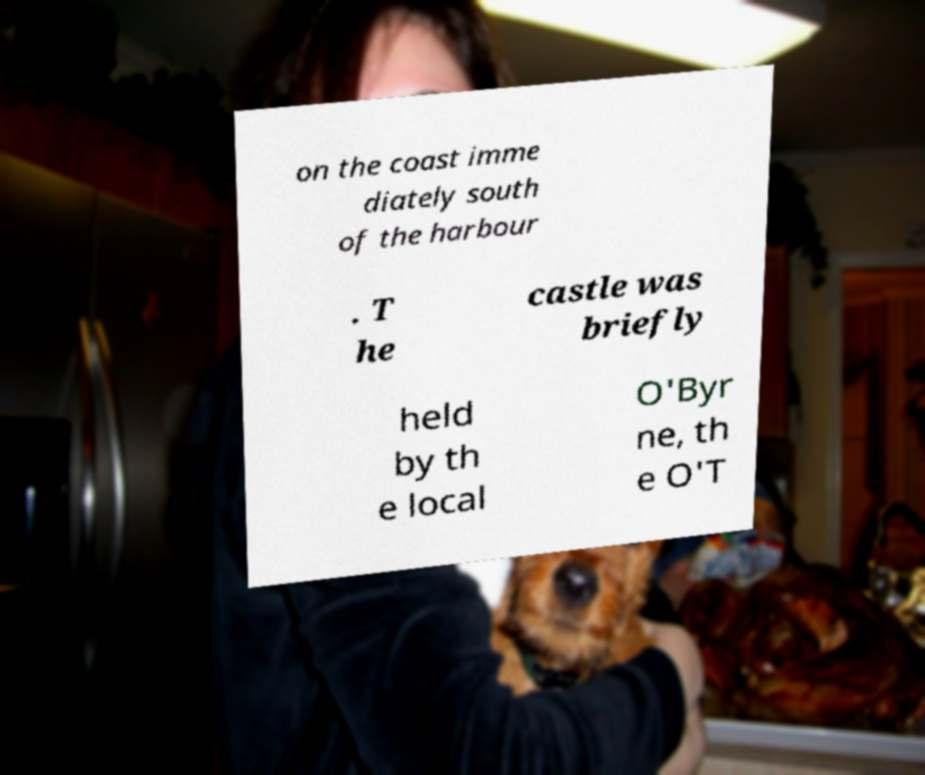For documentation purposes, I need the text within this image transcribed. Could you provide that? on the coast imme diately south of the harbour . T he castle was briefly held by th e local O'Byr ne, th e O'T 